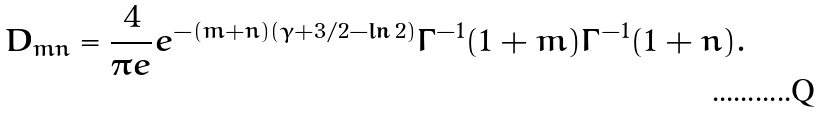Convert formula to latex. <formula><loc_0><loc_0><loc_500><loc_500>D _ { m n } = \frac { 4 } { \pi e } e ^ { - ( m + n ) ( \gamma + 3 / 2 - \ln 2 ) } \Gamma ^ { - 1 } ( 1 + m ) \Gamma ^ { - 1 } ( 1 + n ) .</formula> 